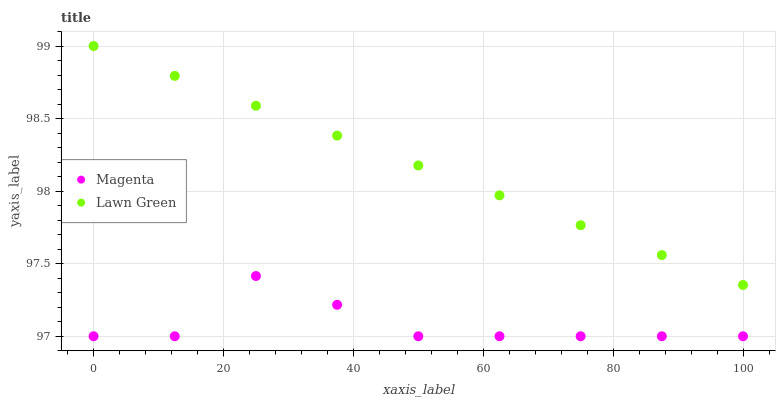Does Magenta have the minimum area under the curve?
Answer yes or no. Yes. Does Lawn Green have the maximum area under the curve?
Answer yes or no. Yes. Does Magenta have the maximum area under the curve?
Answer yes or no. No. Is Lawn Green the smoothest?
Answer yes or no. Yes. Is Magenta the roughest?
Answer yes or no. Yes. Is Magenta the smoothest?
Answer yes or no. No. Does Magenta have the lowest value?
Answer yes or no. Yes. Does Lawn Green have the highest value?
Answer yes or no. Yes. Does Magenta have the highest value?
Answer yes or no. No. Is Magenta less than Lawn Green?
Answer yes or no. Yes. Is Lawn Green greater than Magenta?
Answer yes or no. Yes. Does Magenta intersect Lawn Green?
Answer yes or no. No. 